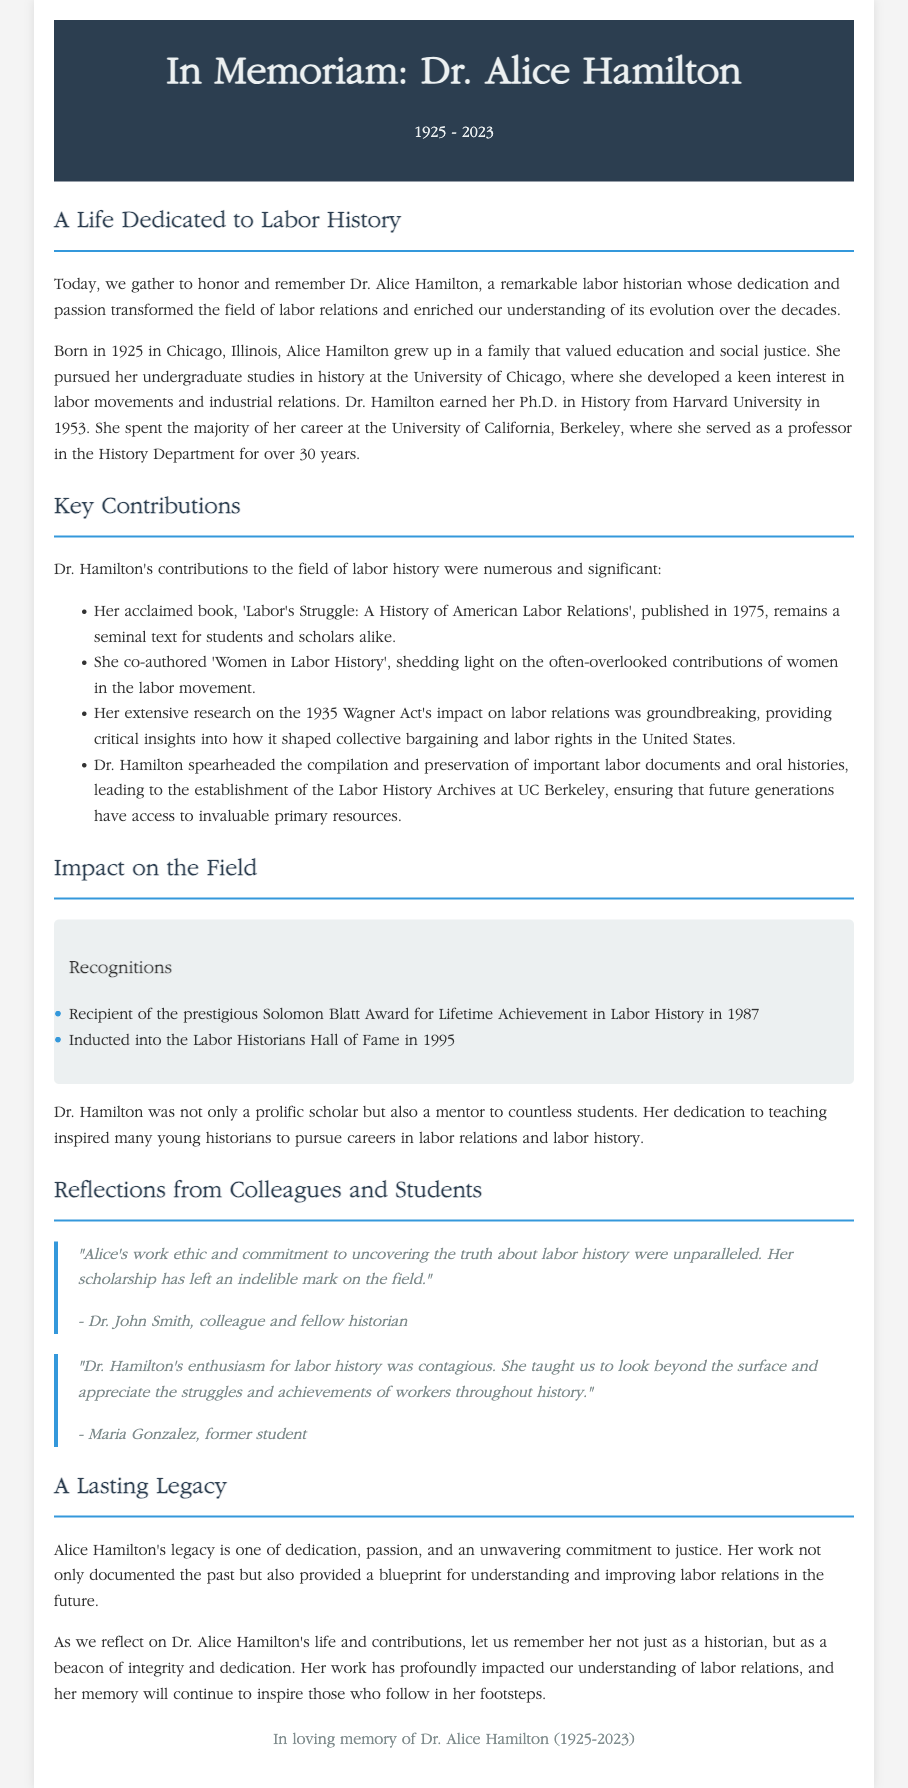What year was Dr. Alice Hamilton born? The document states that Dr. Alice Hamilton was born in 1925.
Answer: 1925 What is the title of Dr. Hamilton's acclaimed book? The document mentions Dr. Hamilton's acclaimed book as 'Labor's Struggle: A History of American Labor Relations'.
Answer: Labor's Struggle: A History of American Labor Relations Which award did Dr. Hamilton receive in 1987? The document notes that Dr. Hamilton received the Solomon Blatt Award for Lifetime Achievement in Labor History in 1987.
Answer: Solomon Blatt Award What is significant about the Labor History Archives at UC Berkeley? The document states that Dr. Hamilton spearheaded the compilation and preservation of important labor documents and oral histories, leading to the establishment of the Labor History Archives at UC Berkeley.
Answer: Labor History Archives Who expressed that Dr. Hamilton’s enthusiasm for labor history was contagious? The quote from Maria Gonzalez, a former student, reflects this sentiment about Dr. Hamilton's enthusiasm for labor history.
Answer: Maria Gonzalez What was one of the impacts of Dr. Hamilton’s extensive research on the Wagner Act? The document indicates that her research provided critical insights into how it shaped collective bargaining and labor rights in the United States.
Answer: Shaped collective bargaining and labor rights What is the primary aim of the memorial eulogy? The main purpose of the eulogy is to honor and remember Dr. Alice Hamilton and her contributions to labor history.
Answer: Honor and remember Dr. Alice Hamilton What did Dr. Hamilton inspire many young historians to pursue? The document states that Dr. Hamilton inspired many young historians to pursue careers in labor relations and labor history.
Answer: Careers in labor relations and labor history 